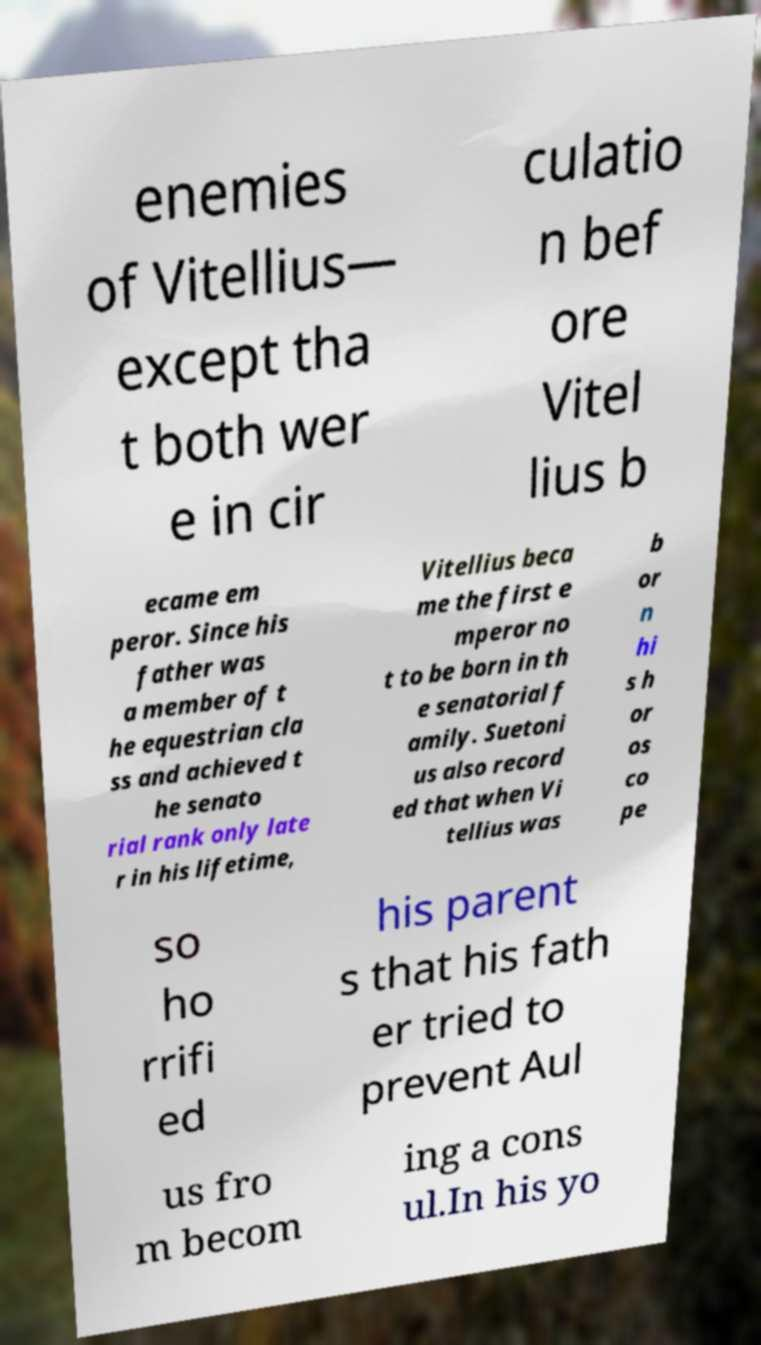For documentation purposes, I need the text within this image transcribed. Could you provide that? enemies of Vitellius— except tha t both wer e in cir culatio n bef ore Vitel lius b ecame em peror. Since his father was a member of t he equestrian cla ss and achieved t he senato rial rank only late r in his lifetime, Vitellius beca me the first e mperor no t to be born in th e senatorial f amily. Suetoni us also record ed that when Vi tellius was b or n hi s h or os co pe so ho rrifi ed his parent s that his fath er tried to prevent Aul us fro m becom ing a cons ul.In his yo 